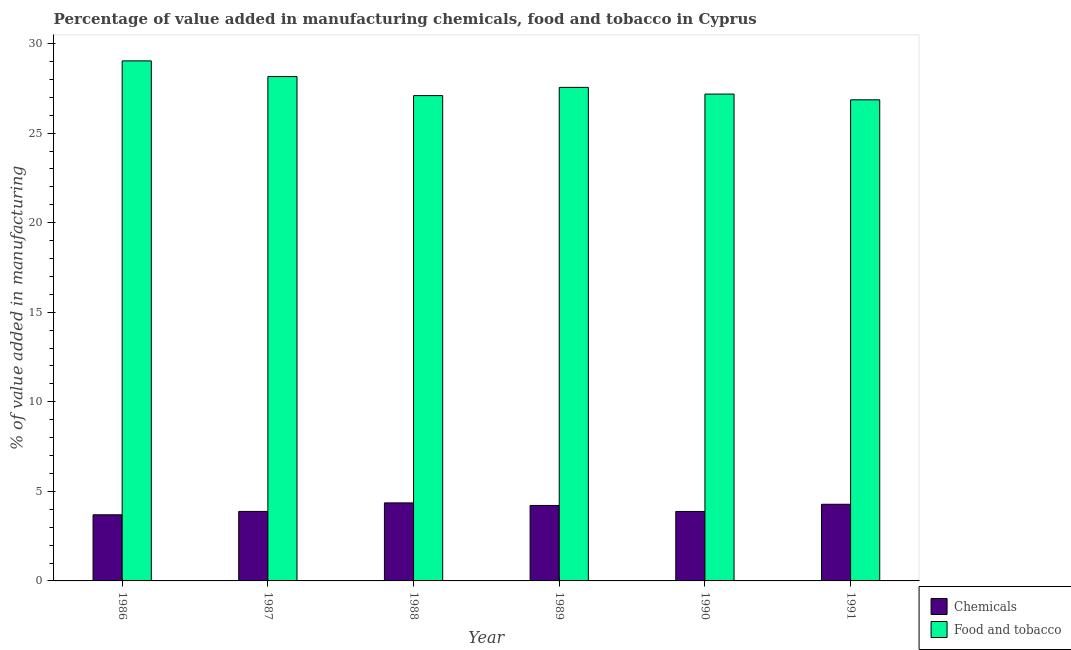How many different coloured bars are there?
Your answer should be compact. 2. How many groups of bars are there?
Provide a succinct answer. 6. Are the number of bars per tick equal to the number of legend labels?
Give a very brief answer. Yes. Are the number of bars on each tick of the X-axis equal?
Make the answer very short. Yes. What is the label of the 6th group of bars from the left?
Provide a succinct answer. 1991. In how many cases, is the number of bars for a given year not equal to the number of legend labels?
Give a very brief answer. 0. What is the value added by  manufacturing chemicals in 1991?
Keep it short and to the point. 4.28. Across all years, what is the maximum value added by  manufacturing chemicals?
Your response must be concise. 4.36. Across all years, what is the minimum value added by  manufacturing chemicals?
Offer a terse response. 3.69. In which year was the value added by  manufacturing chemicals minimum?
Offer a terse response. 1986. What is the total value added by  manufacturing chemicals in the graph?
Ensure brevity in your answer.  24.3. What is the difference between the value added by manufacturing food and tobacco in 1986 and that in 1991?
Your response must be concise. 2.17. What is the difference between the value added by  manufacturing chemicals in 1986 and the value added by manufacturing food and tobacco in 1989?
Provide a short and direct response. -0.52. What is the average value added by  manufacturing chemicals per year?
Your answer should be compact. 4.05. What is the ratio of the value added by manufacturing food and tobacco in 1988 to that in 1989?
Your response must be concise. 0.98. What is the difference between the highest and the second highest value added by manufacturing food and tobacco?
Offer a terse response. 0.88. What is the difference between the highest and the lowest value added by  manufacturing chemicals?
Keep it short and to the point. 0.66. In how many years, is the value added by manufacturing food and tobacco greater than the average value added by manufacturing food and tobacco taken over all years?
Your response must be concise. 2. What does the 1st bar from the left in 1990 represents?
Provide a succinct answer. Chemicals. What does the 2nd bar from the right in 1989 represents?
Ensure brevity in your answer.  Chemicals. Are all the bars in the graph horizontal?
Provide a short and direct response. No. How many years are there in the graph?
Ensure brevity in your answer.  6. What is the difference between two consecutive major ticks on the Y-axis?
Ensure brevity in your answer.  5. Does the graph contain any zero values?
Make the answer very short. No. What is the title of the graph?
Your response must be concise. Percentage of value added in manufacturing chemicals, food and tobacco in Cyprus. Does "Non-pregnant women" appear as one of the legend labels in the graph?
Provide a succinct answer. No. What is the label or title of the X-axis?
Provide a succinct answer. Year. What is the label or title of the Y-axis?
Keep it short and to the point. % of value added in manufacturing. What is the % of value added in manufacturing of Chemicals in 1986?
Your answer should be compact. 3.69. What is the % of value added in manufacturing of Food and tobacco in 1986?
Ensure brevity in your answer.  29.04. What is the % of value added in manufacturing of Chemicals in 1987?
Keep it short and to the point. 3.88. What is the % of value added in manufacturing in Food and tobacco in 1987?
Your answer should be very brief. 28.16. What is the % of value added in manufacturing in Chemicals in 1988?
Offer a very short reply. 4.36. What is the % of value added in manufacturing in Food and tobacco in 1988?
Provide a succinct answer. 27.1. What is the % of value added in manufacturing of Chemicals in 1989?
Provide a succinct answer. 4.21. What is the % of value added in manufacturing of Food and tobacco in 1989?
Your response must be concise. 27.56. What is the % of value added in manufacturing of Chemicals in 1990?
Give a very brief answer. 3.88. What is the % of value added in manufacturing in Food and tobacco in 1990?
Your answer should be very brief. 27.18. What is the % of value added in manufacturing of Chemicals in 1991?
Provide a succinct answer. 4.28. What is the % of value added in manufacturing in Food and tobacco in 1991?
Ensure brevity in your answer.  26.86. Across all years, what is the maximum % of value added in manufacturing of Chemicals?
Give a very brief answer. 4.36. Across all years, what is the maximum % of value added in manufacturing in Food and tobacco?
Give a very brief answer. 29.04. Across all years, what is the minimum % of value added in manufacturing of Chemicals?
Provide a short and direct response. 3.69. Across all years, what is the minimum % of value added in manufacturing in Food and tobacco?
Provide a succinct answer. 26.86. What is the total % of value added in manufacturing of Chemicals in the graph?
Your answer should be very brief. 24.3. What is the total % of value added in manufacturing of Food and tobacco in the graph?
Make the answer very short. 165.89. What is the difference between the % of value added in manufacturing in Chemicals in 1986 and that in 1987?
Your response must be concise. -0.19. What is the difference between the % of value added in manufacturing of Food and tobacco in 1986 and that in 1987?
Your answer should be compact. 0.88. What is the difference between the % of value added in manufacturing of Chemicals in 1986 and that in 1988?
Offer a terse response. -0.66. What is the difference between the % of value added in manufacturing in Food and tobacco in 1986 and that in 1988?
Keep it short and to the point. 1.94. What is the difference between the % of value added in manufacturing of Chemicals in 1986 and that in 1989?
Your answer should be very brief. -0.52. What is the difference between the % of value added in manufacturing of Food and tobacco in 1986 and that in 1989?
Offer a terse response. 1.48. What is the difference between the % of value added in manufacturing of Chemicals in 1986 and that in 1990?
Provide a succinct answer. -0.19. What is the difference between the % of value added in manufacturing of Food and tobacco in 1986 and that in 1990?
Your answer should be compact. 1.85. What is the difference between the % of value added in manufacturing of Chemicals in 1986 and that in 1991?
Give a very brief answer. -0.59. What is the difference between the % of value added in manufacturing of Food and tobacco in 1986 and that in 1991?
Ensure brevity in your answer.  2.17. What is the difference between the % of value added in manufacturing of Chemicals in 1987 and that in 1988?
Your answer should be very brief. -0.48. What is the difference between the % of value added in manufacturing of Food and tobacco in 1987 and that in 1988?
Make the answer very short. 1.06. What is the difference between the % of value added in manufacturing in Chemicals in 1987 and that in 1989?
Offer a very short reply. -0.33. What is the difference between the % of value added in manufacturing in Food and tobacco in 1987 and that in 1989?
Ensure brevity in your answer.  0.6. What is the difference between the % of value added in manufacturing in Chemicals in 1987 and that in 1990?
Offer a very short reply. 0. What is the difference between the % of value added in manufacturing in Food and tobacco in 1987 and that in 1990?
Make the answer very short. 0.98. What is the difference between the % of value added in manufacturing of Chemicals in 1987 and that in 1991?
Give a very brief answer. -0.4. What is the difference between the % of value added in manufacturing of Food and tobacco in 1987 and that in 1991?
Provide a short and direct response. 1.3. What is the difference between the % of value added in manufacturing in Chemicals in 1988 and that in 1989?
Offer a very short reply. 0.14. What is the difference between the % of value added in manufacturing of Food and tobacco in 1988 and that in 1989?
Your response must be concise. -0.46. What is the difference between the % of value added in manufacturing of Chemicals in 1988 and that in 1990?
Keep it short and to the point. 0.48. What is the difference between the % of value added in manufacturing of Food and tobacco in 1988 and that in 1990?
Give a very brief answer. -0.09. What is the difference between the % of value added in manufacturing of Chemicals in 1988 and that in 1991?
Provide a succinct answer. 0.08. What is the difference between the % of value added in manufacturing of Food and tobacco in 1988 and that in 1991?
Your response must be concise. 0.24. What is the difference between the % of value added in manufacturing in Chemicals in 1989 and that in 1990?
Ensure brevity in your answer.  0.34. What is the difference between the % of value added in manufacturing of Food and tobacco in 1989 and that in 1990?
Make the answer very short. 0.37. What is the difference between the % of value added in manufacturing in Chemicals in 1989 and that in 1991?
Keep it short and to the point. -0.07. What is the difference between the % of value added in manufacturing of Food and tobacco in 1989 and that in 1991?
Your answer should be very brief. 0.69. What is the difference between the % of value added in manufacturing in Chemicals in 1990 and that in 1991?
Offer a terse response. -0.4. What is the difference between the % of value added in manufacturing in Food and tobacco in 1990 and that in 1991?
Provide a succinct answer. 0.32. What is the difference between the % of value added in manufacturing of Chemicals in 1986 and the % of value added in manufacturing of Food and tobacco in 1987?
Your response must be concise. -24.47. What is the difference between the % of value added in manufacturing in Chemicals in 1986 and the % of value added in manufacturing in Food and tobacco in 1988?
Your answer should be compact. -23.4. What is the difference between the % of value added in manufacturing of Chemicals in 1986 and the % of value added in manufacturing of Food and tobacco in 1989?
Provide a short and direct response. -23.86. What is the difference between the % of value added in manufacturing of Chemicals in 1986 and the % of value added in manufacturing of Food and tobacco in 1990?
Provide a succinct answer. -23.49. What is the difference between the % of value added in manufacturing in Chemicals in 1986 and the % of value added in manufacturing in Food and tobacco in 1991?
Offer a very short reply. -23.17. What is the difference between the % of value added in manufacturing in Chemicals in 1987 and the % of value added in manufacturing in Food and tobacco in 1988?
Your answer should be very brief. -23.22. What is the difference between the % of value added in manufacturing in Chemicals in 1987 and the % of value added in manufacturing in Food and tobacco in 1989?
Provide a succinct answer. -23.68. What is the difference between the % of value added in manufacturing in Chemicals in 1987 and the % of value added in manufacturing in Food and tobacco in 1990?
Offer a very short reply. -23.3. What is the difference between the % of value added in manufacturing in Chemicals in 1987 and the % of value added in manufacturing in Food and tobacco in 1991?
Make the answer very short. -22.98. What is the difference between the % of value added in manufacturing of Chemicals in 1988 and the % of value added in manufacturing of Food and tobacco in 1989?
Your answer should be compact. -23.2. What is the difference between the % of value added in manufacturing in Chemicals in 1988 and the % of value added in manufacturing in Food and tobacco in 1990?
Make the answer very short. -22.83. What is the difference between the % of value added in manufacturing of Chemicals in 1988 and the % of value added in manufacturing of Food and tobacco in 1991?
Provide a succinct answer. -22.5. What is the difference between the % of value added in manufacturing of Chemicals in 1989 and the % of value added in manufacturing of Food and tobacco in 1990?
Offer a terse response. -22.97. What is the difference between the % of value added in manufacturing in Chemicals in 1989 and the % of value added in manufacturing in Food and tobacco in 1991?
Your response must be concise. -22.65. What is the difference between the % of value added in manufacturing in Chemicals in 1990 and the % of value added in manufacturing in Food and tobacco in 1991?
Offer a very short reply. -22.98. What is the average % of value added in manufacturing of Chemicals per year?
Your answer should be very brief. 4.05. What is the average % of value added in manufacturing in Food and tobacco per year?
Give a very brief answer. 27.65. In the year 1986, what is the difference between the % of value added in manufacturing in Chemicals and % of value added in manufacturing in Food and tobacco?
Make the answer very short. -25.34. In the year 1987, what is the difference between the % of value added in manufacturing in Chemicals and % of value added in manufacturing in Food and tobacco?
Your response must be concise. -24.28. In the year 1988, what is the difference between the % of value added in manufacturing in Chemicals and % of value added in manufacturing in Food and tobacco?
Make the answer very short. -22.74. In the year 1989, what is the difference between the % of value added in manufacturing in Chemicals and % of value added in manufacturing in Food and tobacco?
Offer a terse response. -23.34. In the year 1990, what is the difference between the % of value added in manufacturing of Chemicals and % of value added in manufacturing of Food and tobacco?
Your answer should be compact. -23.3. In the year 1991, what is the difference between the % of value added in manufacturing in Chemicals and % of value added in manufacturing in Food and tobacco?
Keep it short and to the point. -22.58. What is the ratio of the % of value added in manufacturing in Chemicals in 1986 to that in 1987?
Provide a succinct answer. 0.95. What is the ratio of the % of value added in manufacturing in Food and tobacco in 1986 to that in 1987?
Give a very brief answer. 1.03. What is the ratio of the % of value added in manufacturing in Chemicals in 1986 to that in 1988?
Give a very brief answer. 0.85. What is the ratio of the % of value added in manufacturing in Food and tobacco in 1986 to that in 1988?
Offer a terse response. 1.07. What is the ratio of the % of value added in manufacturing in Chemicals in 1986 to that in 1989?
Provide a short and direct response. 0.88. What is the ratio of the % of value added in manufacturing in Food and tobacco in 1986 to that in 1989?
Give a very brief answer. 1.05. What is the ratio of the % of value added in manufacturing of Chemicals in 1986 to that in 1990?
Offer a terse response. 0.95. What is the ratio of the % of value added in manufacturing in Food and tobacco in 1986 to that in 1990?
Keep it short and to the point. 1.07. What is the ratio of the % of value added in manufacturing in Chemicals in 1986 to that in 1991?
Provide a short and direct response. 0.86. What is the ratio of the % of value added in manufacturing of Food and tobacco in 1986 to that in 1991?
Offer a terse response. 1.08. What is the ratio of the % of value added in manufacturing in Chemicals in 1987 to that in 1988?
Your response must be concise. 0.89. What is the ratio of the % of value added in manufacturing of Food and tobacco in 1987 to that in 1988?
Provide a short and direct response. 1.04. What is the ratio of the % of value added in manufacturing of Chemicals in 1987 to that in 1989?
Offer a terse response. 0.92. What is the ratio of the % of value added in manufacturing of Food and tobacco in 1987 to that in 1989?
Offer a very short reply. 1.02. What is the ratio of the % of value added in manufacturing of Chemicals in 1987 to that in 1990?
Your response must be concise. 1. What is the ratio of the % of value added in manufacturing of Food and tobacco in 1987 to that in 1990?
Keep it short and to the point. 1.04. What is the ratio of the % of value added in manufacturing in Chemicals in 1987 to that in 1991?
Give a very brief answer. 0.91. What is the ratio of the % of value added in manufacturing in Food and tobacco in 1987 to that in 1991?
Your answer should be very brief. 1.05. What is the ratio of the % of value added in manufacturing in Chemicals in 1988 to that in 1989?
Provide a succinct answer. 1.03. What is the ratio of the % of value added in manufacturing in Food and tobacco in 1988 to that in 1989?
Give a very brief answer. 0.98. What is the ratio of the % of value added in manufacturing of Chemicals in 1988 to that in 1990?
Provide a succinct answer. 1.12. What is the ratio of the % of value added in manufacturing of Chemicals in 1988 to that in 1991?
Your answer should be compact. 1.02. What is the ratio of the % of value added in manufacturing of Food and tobacco in 1988 to that in 1991?
Your response must be concise. 1.01. What is the ratio of the % of value added in manufacturing in Chemicals in 1989 to that in 1990?
Offer a very short reply. 1.09. What is the ratio of the % of value added in manufacturing of Food and tobacco in 1989 to that in 1990?
Provide a short and direct response. 1.01. What is the ratio of the % of value added in manufacturing in Chemicals in 1989 to that in 1991?
Offer a very short reply. 0.98. What is the ratio of the % of value added in manufacturing in Food and tobacco in 1989 to that in 1991?
Offer a terse response. 1.03. What is the ratio of the % of value added in manufacturing of Chemicals in 1990 to that in 1991?
Provide a succinct answer. 0.91. What is the ratio of the % of value added in manufacturing of Food and tobacco in 1990 to that in 1991?
Make the answer very short. 1.01. What is the difference between the highest and the second highest % of value added in manufacturing in Chemicals?
Provide a succinct answer. 0.08. What is the difference between the highest and the second highest % of value added in manufacturing in Food and tobacco?
Offer a very short reply. 0.88. What is the difference between the highest and the lowest % of value added in manufacturing in Chemicals?
Ensure brevity in your answer.  0.66. What is the difference between the highest and the lowest % of value added in manufacturing in Food and tobacco?
Offer a very short reply. 2.17. 